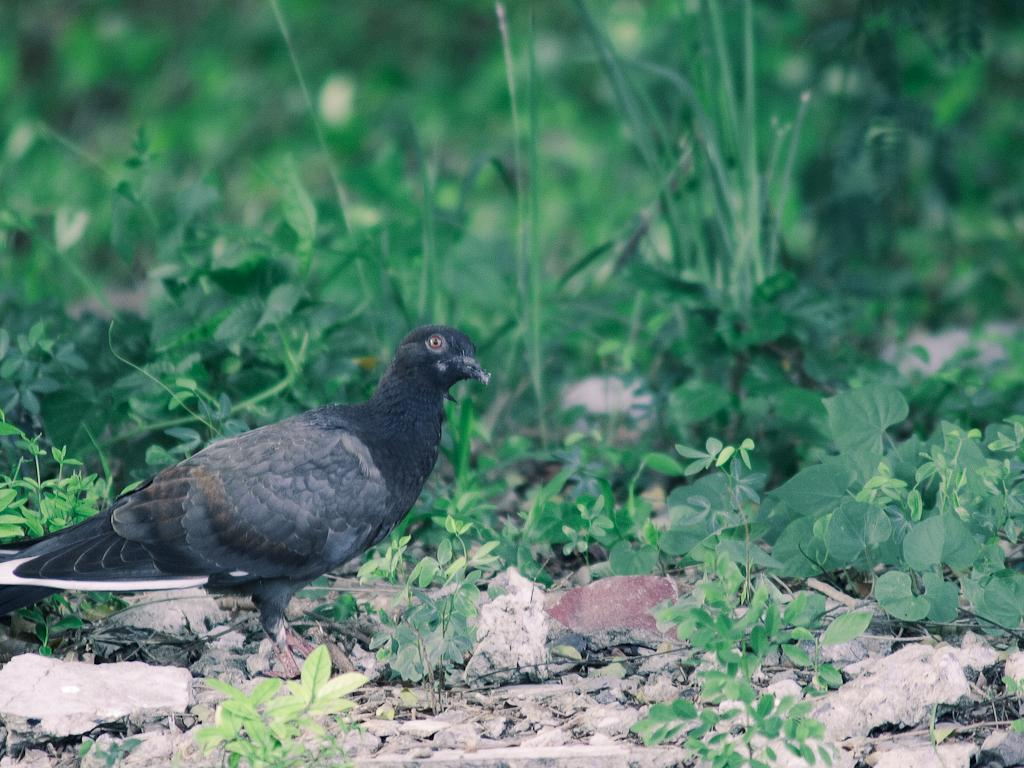What type of animal can be seen in the image? There is a bird in the image. Where is the bird located in the image? The bird is standing on the ground. What can be seen in the background of the image? There are plants in the background of the image. When was the image taken? The image was taken during the day. How many jars of jam are visible in the image? There are no jars of jam present in the image. What type of school is depicted in the image? There is no school present in the image; it features a bird standing on the ground with plants in the background. 